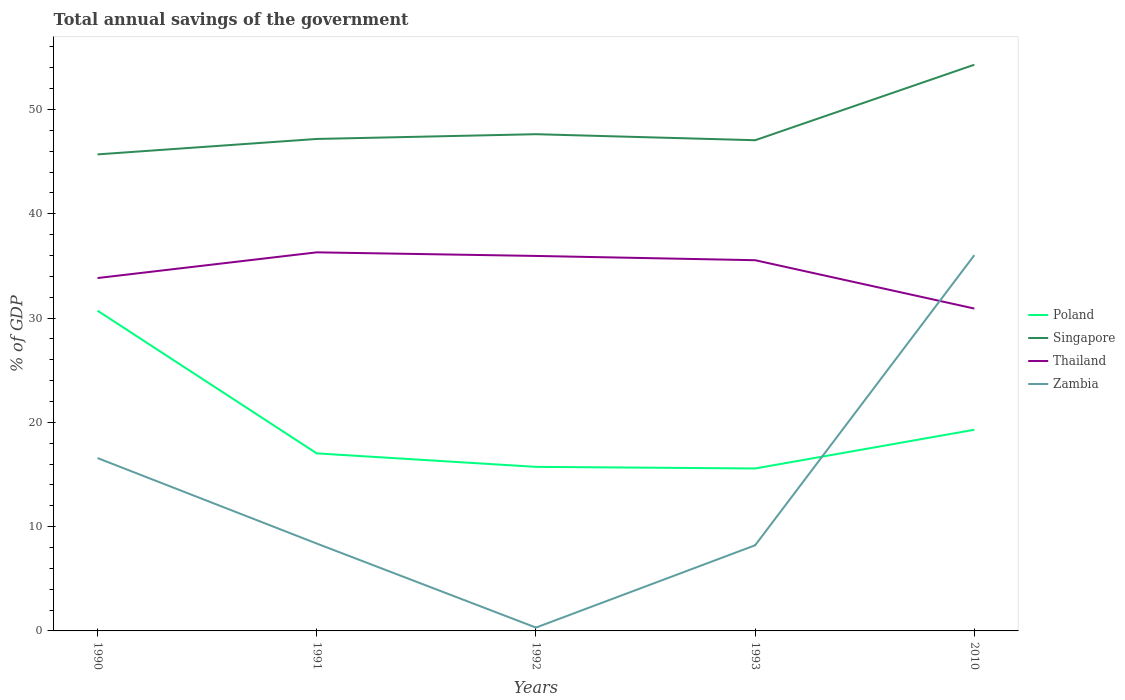How many different coloured lines are there?
Your response must be concise. 4. Does the line corresponding to Singapore intersect with the line corresponding to Thailand?
Provide a succinct answer. No. Across all years, what is the maximum total annual savings of the government in Poland?
Your response must be concise. 15.58. In which year was the total annual savings of the government in Zambia maximum?
Offer a terse response. 1992. What is the total total annual savings of the government in Zambia in the graph?
Provide a succinct answer. -7.89. What is the difference between the highest and the second highest total annual savings of the government in Thailand?
Ensure brevity in your answer.  5.39. How many years are there in the graph?
Your response must be concise. 5. Are the values on the major ticks of Y-axis written in scientific E-notation?
Your answer should be compact. No. Does the graph contain grids?
Keep it short and to the point. No. How are the legend labels stacked?
Ensure brevity in your answer.  Vertical. What is the title of the graph?
Ensure brevity in your answer.  Total annual savings of the government. What is the label or title of the X-axis?
Offer a terse response. Years. What is the label or title of the Y-axis?
Your answer should be very brief. % of GDP. What is the % of GDP of Poland in 1990?
Give a very brief answer. 30.7. What is the % of GDP of Singapore in 1990?
Offer a terse response. 45.69. What is the % of GDP in Thailand in 1990?
Offer a terse response. 33.84. What is the % of GDP in Zambia in 1990?
Provide a succinct answer. 16.57. What is the % of GDP of Poland in 1991?
Offer a terse response. 17.02. What is the % of GDP in Singapore in 1991?
Keep it short and to the point. 47.17. What is the % of GDP in Thailand in 1991?
Your answer should be compact. 36.3. What is the % of GDP of Zambia in 1991?
Your answer should be very brief. 8.38. What is the % of GDP in Poland in 1992?
Offer a very short reply. 15.73. What is the % of GDP of Singapore in 1992?
Offer a terse response. 47.63. What is the % of GDP in Thailand in 1992?
Offer a terse response. 35.95. What is the % of GDP in Zambia in 1992?
Keep it short and to the point. 0.32. What is the % of GDP in Poland in 1993?
Your answer should be very brief. 15.58. What is the % of GDP of Singapore in 1993?
Provide a succinct answer. 47.05. What is the % of GDP in Thailand in 1993?
Make the answer very short. 35.54. What is the % of GDP in Zambia in 1993?
Your answer should be very brief. 8.21. What is the % of GDP of Poland in 2010?
Keep it short and to the point. 19.29. What is the % of GDP of Singapore in 2010?
Provide a succinct answer. 54.29. What is the % of GDP of Thailand in 2010?
Offer a very short reply. 30.91. What is the % of GDP in Zambia in 2010?
Ensure brevity in your answer.  36.03. Across all years, what is the maximum % of GDP of Poland?
Ensure brevity in your answer.  30.7. Across all years, what is the maximum % of GDP of Singapore?
Your answer should be very brief. 54.29. Across all years, what is the maximum % of GDP of Thailand?
Keep it short and to the point. 36.3. Across all years, what is the maximum % of GDP in Zambia?
Your response must be concise. 36.03. Across all years, what is the minimum % of GDP in Poland?
Give a very brief answer. 15.58. Across all years, what is the minimum % of GDP in Singapore?
Ensure brevity in your answer.  45.69. Across all years, what is the minimum % of GDP of Thailand?
Provide a succinct answer. 30.91. Across all years, what is the minimum % of GDP in Zambia?
Your answer should be very brief. 0.32. What is the total % of GDP in Poland in the graph?
Your answer should be compact. 98.32. What is the total % of GDP in Singapore in the graph?
Make the answer very short. 241.83. What is the total % of GDP in Thailand in the graph?
Give a very brief answer. 172.54. What is the total % of GDP of Zambia in the graph?
Provide a succinct answer. 69.51. What is the difference between the % of GDP of Poland in 1990 and that in 1991?
Ensure brevity in your answer.  13.68. What is the difference between the % of GDP of Singapore in 1990 and that in 1991?
Offer a terse response. -1.48. What is the difference between the % of GDP of Thailand in 1990 and that in 1991?
Ensure brevity in your answer.  -2.46. What is the difference between the % of GDP of Zambia in 1990 and that in 1991?
Provide a succinct answer. 8.19. What is the difference between the % of GDP in Poland in 1990 and that in 1992?
Keep it short and to the point. 14.97. What is the difference between the % of GDP in Singapore in 1990 and that in 1992?
Give a very brief answer. -1.93. What is the difference between the % of GDP in Thailand in 1990 and that in 1992?
Your answer should be compact. -2.12. What is the difference between the % of GDP of Zambia in 1990 and that in 1992?
Offer a very short reply. 16.25. What is the difference between the % of GDP in Poland in 1990 and that in 1993?
Give a very brief answer. 15.13. What is the difference between the % of GDP in Singapore in 1990 and that in 1993?
Your answer should be compact. -1.36. What is the difference between the % of GDP of Thailand in 1990 and that in 1993?
Your response must be concise. -1.71. What is the difference between the % of GDP of Zambia in 1990 and that in 1993?
Make the answer very short. 8.36. What is the difference between the % of GDP in Poland in 1990 and that in 2010?
Offer a very short reply. 11.42. What is the difference between the % of GDP of Singapore in 1990 and that in 2010?
Your answer should be compact. -8.6. What is the difference between the % of GDP in Thailand in 1990 and that in 2010?
Your answer should be compact. 2.93. What is the difference between the % of GDP in Zambia in 1990 and that in 2010?
Keep it short and to the point. -19.46. What is the difference between the % of GDP of Poland in 1991 and that in 1992?
Provide a succinct answer. 1.29. What is the difference between the % of GDP of Singapore in 1991 and that in 1992?
Your answer should be compact. -0.46. What is the difference between the % of GDP of Thailand in 1991 and that in 1992?
Offer a terse response. 0.34. What is the difference between the % of GDP of Zambia in 1991 and that in 1992?
Offer a terse response. 8.06. What is the difference between the % of GDP in Poland in 1991 and that in 1993?
Give a very brief answer. 1.45. What is the difference between the % of GDP in Singapore in 1991 and that in 1993?
Offer a terse response. 0.12. What is the difference between the % of GDP of Thailand in 1991 and that in 1993?
Your response must be concise. 0.75. What is the difference between the % of GDP of Zambia in 1991 and that in 1993?
Keep it short and to the point. 0.17. What is the difference between the % of GDP of Poland in 1991 and that in 2010?
Provide a succinct answer. -2.27. What is the difference between the % of GDP in Singapore in 1991 and that in 2010?
Ensure brevity in your answer.  -7.12. What is the difference between the % of GDP of Thailand in 1991 and that in 2010?
Ensure brevity in your answer.  5.39. What is the difference between the % of GDP of Zambia in 1991 and that in 2010?
Your response must be concise. -27.65. What is the difference between the % of GDP of Poland in 1992 and that in 1993?
Keep it short and to the point. 0.15. What is the difference between the % of GDP of Singapore in 1992 and that in 1993?
Make the answer very short. 0.58. What is the difference between the % of GDP in Thailand in 1992 and that in 1993?
Keep it short and to the point. 0.41. What is the difference between the % of GDP in Zambia in 1992 and that in 1993?
Keep it short and to the point. -7.89. What is the difference between the % of GDP of Poland in 1992 and that in 2010?
Ensure brevity in your answer.  -3.56. What is the difference between the % of GDP in Singapore in 1992 and that in 2010?
Make the answer very short. -6.66. What is the difference between the % of GDP in Thailand in 1992 and that in 2010?
Provide a short and direct response. 5.05. What is the difference between the % of GDP of Zambia in 1992 and that in 2010?
Your answer should be compact. -35.71. What is the difference between the % of GDP in Poland in 1993 and that in 2010?
Your response must be concise. -3.71. What is the difference between the % of GDP of Singapore in 1993 and that in 2010?
Ensure brevity in your answer.  -7.24. What is the difference between the % of GDP in Thailand in 1993 and that in 2010?
Give a very brief answer. 4.64. What is the difference between the % of GDP in Zambia in 1993 and that in 2010?
Make the answer very short. -27.82. What is the difference between the % of GDP of Poland in 1990 and the % of GDP of Singapore in 1991?
Your answer should be compact. -16.47. What is the difference between the % of GDP in Poland in 1990 and the % of GDP in Thailand in 1991?
Offer a terse response. -5.59. What is the difference between the % of GDP in Poland in 1990 and the % of GDP in Zambia in 1991?
Your answer should be compact. 22.33. What is the difference between the % of GDP of Singapore in 1990 and the % of GDP of Thailand in 1991?
Your response must be concise. 9.39. What is the difference between the % of GDP in Singapore in 1990 and the % of GDP in Zambia in 1991?
Offer a very short reply. 37.31. What is the difference between the % of GDP of Thailand in 1990 and the % of GDP of Zambia in 1991?
Ensure brevity in your answer.  25.46. What is the difference between the % of GDP of Poland in 1990 and the % of GDP of Singapore in 1992?
Make the answer very short. -16.92. What is the difference between the % of GDP of Poland in 1990 and the % of GDP of Thailand in 1992?
Make the answer very short. -5.25. What is the difference between the % of GDP in Poland in 1990 and the % of GDP in Zambia in 1992?
Your answer should be compact. 30.38. What is the difference between the % of GDP in Singapore in 1990 and the % of GDP in Thailand in 1992?
Give a very brief answer. 9.74. What is the difference between the % of GDP of Singapore in 1990 and the % of GDP of Zambia in 1992?
Offer a terse response. 45.37. What is the difference between the % of GDP in Thailand in 1990 and the % of GDP in Zambia in 1992?
Your answer should be compact. 33.51. What is the difference between the % of GDP of Poland in 1990 and the % of GDP of Singapore in 1993?
Your answer should be compact. -16.34. What is the difference between the % of GDP in Poland in 1990 and the % of GDP in Thailand in 1993?
Provide a short and direct response. -4.84. What is the difference between the % of GDP in Poland in 1990 and the % of GDP in Zambia in 1993?
Your answer should be compact. 22.49. What is the difference between the % of GDP of Singapore in 1990 and the % of GDP of Thailand in 1993?
Your answer should be very brief. 10.15. What is the difference between the % of GDP in Singapore in 1990 and the % of GDP in Zambia in 1993?
Offer a very short reply. 37.48. What is the difference between the % of GDP in Thailand in 1990 and the % of GDP in Zambia in 1993?
Ensure brevity in your answer.  25.62. What is the difference between the % of GDP in Poland in 1990 and the % of GDP in Singapore in 2010?
Offer a terse response. -23.58. What is the difference between the % of GDP of Poland in 1990 and the % of GDP of Thailand in 2010?
Your answer should be compact. -0.2. What is the difference between the % of GDP of Poland in 1990 and the % of GDP of Zambia in 2010?
Offer a very short reply. -5.32. What is the difference between the % of GDP in Singapore in 1990 and the % of GDP in Thailand in 2010?
Your response must be concise. 14.78. What is the difference between the % of GDP of Singapore in 1990 and the % of GDP of Zambia in 2010?
Make the answer very short. 9.66. What is the difference between the % of GDP in Thailand in 1990 and the % of GDP in Zambia in 2010?
Make the answer very short. -2.19. What is the difference between the % of GDP in Poland in 1991 and the % of GDP in Singapore in 1992?
Your response must be concise. -30.6. What is the difference between the % of GDP in Poland in 1991 and the % of GDP in Thailand in 1992?
Your response must be concise. -18.93. What is the difference between the % of GDP in Poland in 1991 and the % of GDP in Zambia in 1992?
Your response must be concise. 16.7. What is the difference between the % of GDP in Singapore in 1991 and the % of GDP in Thailand in 1992?
Your answer should be very brief. 11.22. What is the difference between the % of GDP in Singapore in 1991 and the % of GDP in Zambia in 1992?
Ensure brevity in your answer.  46.85. What is the difference between the % of GDP of Thailand in 1991 and the % of GDP of Zambia in 1992?
Your answer should be compact. 35.98. What is the difference between the % of GDP of Poland in 1991 and the % of GDP of Singapore in 1993?
Provide a short and direct response. -30.03. What is the difference between the % of GDP of Poland in 1991 and the % of GDP of Thailand in 1993?
Your response must be concise. -18.52. What is the difference between the % of GDP in Poland in 1991 and the % of GDP in Zambia in 1993?
Provide a succinct answer. 8.81. What is the difference between the % of GDP of Singapore in 1991 and the % of GDP of Thailand in 1993?
Your response must be concise. 11.63. What is the difference between the % of GDP in Singapore in 1991 and the % of GDP in Zambia in 1993?
Offer a terse response. 38.96. What is the difference between the % of GDP of Thailand in 1991 and the % of GDP of Zambia in 1993?
Your answer should be very brief. 28.09. What is the difference between the % of GDP in Poland in 1991 and the % of GDP in Singapore in 2010?
Keep it short and to the point. -37.27. What is the difference between the % of GDP of Poland in 1991 and the % of GDP of Thailand in 2010?
Your answer should be very brief. -13.89. What is the difference between the % of GDP in Poland in 1991 and the % of GDP in Zambia in 2010?
Make the answer very short. -19.01. What is the difference between the % of GDP in Singapore in 1991 and the % of GDP in Thailand in 2010?
Keep it short and to the point. 16.26. What is the difference between the % of GDP of Singapore in 1991 and the % of GDP of Zambia in 2010?
Your response must be concise. 11.14. What is the difference between the % of GDP of Thailand in 1991 and the % of GDP of Zambia in 2010?
Offer a very short reply. 0.27. What is the difference between the % of GDP in Poland in 1992 and the % of GDP in Singapore in 1993?
Keep it short and to the point. -31.32. What is the difference between the % of GDP in Poland in 1992 and the % of GDP in Thailand in 1993?
Ensure brevity in your answer.  -19.81. What is the difference between the % of GDP of Poland in 1992 and the % of GDP of Zambia in 1993?
Offer a terse response. 7.52. What is the difference between the % of GDP of Singapore in 1992 and the % of GDP of Thailand in 1993?
Offer a terse response. 12.08. What is the difference between the % of GDP in Singapore in 1992 and the % of GDP in Zambia in 1993?
Ensure brevity in your answer.  39.41. What is the difference between the % of GDP in Thailand in 1992 and the % of GDP in Zambia in 1993?
Provide a short and direct response. 27.74. What is the difference between the % of GDP of Poland in 1992 and the % of GDP of Singapore in 2010?
Keep it short and to the point. -38.56. What is the difference between the % of GDP in Poland in 1992 and the % of GDP in Thailand in 2010?
Your answer should be very brief. -15.18. What is the difference between the % of GDP of Poland in 1992 and the % of GDP of Zambia in 2010?
Your answer should be compact. -20.3. What is the difference between the % of GDP in Singapore in 1992 and the % of GDP in Thailand in 2010?
Provide a short and direct response. 16.72. What is the difference between the % of GDP in Singapore in 1992 and the % of GDP in Zambia in 2010?
Provide a succinct answer. 11.6. What is the difference between the % of GDP of Thailand in 1992 and the % of GDP of Zambia in 2010?
Provide a succinct answer. -0.07. What is the difference between the % of GDP in Poland in 1993 and the % of GDP in Singapore in 2010?
Give a very brief answer. -38.71. What is the difference between the % of GDP in Poland in 1993 and the % of GDP in Thailand in 2010?
Your response must be concise. -15.33. What is the difference between the % of GDP of Poland in 1993 and the % of GDP of Zambia in 2010?
Provide a succinct answer. -20.45. What is the difference between the % of GDP in Singapore in 1993 and the % of GDP in Thailand in 2010?
Your answer should be very brief. 16.14. What is the difference between the % of GDP in Singapore in 1993 and the % of GDP in Zambia in 2010?
Offer a terse response. 11.02. What is the difference between the % of GDP of Thailand in 1993 and the % of GDP of Zambia in 2010?
Give a very brief answer. -0.48. What is the average % of GDP of Poland per year?
Offer a terse response. 19.66. What is the average % of GDP of Singapore per year?
Offer a very short reply. 48.37. What is the average % of GDP in Thailand per year?
Make the answer very short. 34.51. What is the average % of GDP of Zambia per year?
Provide a short and direct response. 13.9. In the year 1990, what is the difference between the % of GDP of Poland and % of GDP of Singapore?
Offer a very short reply. -14.99. In the year 1990, what is the difference between the % of GDP of Poland and % of GDP of Thailand?
Your answer should be very brief. -3.13. In the year 1990, what is the difference between the % of GDP in Poland and % of GDP in Zambia?
Your answer should be compact. 14.13. In the year 1990, what is the difference between the % of GDP in Singapore and % of GDP in Thailand?
Provide a succinct answer. 11.86. In the year 1990, what is the difference between the % of GDP in Singapore and % of GDP in Zambia?
Make the answer very short. 29.12. In the year 1990, what is the difference between the % of GDP of Thailand and % of GDP of Zambia?
Keep it short and to the point. 17.26. In the year 1991, what is the difference between the % of GDP in Poland and % of GDP in Singapore?
Offer a terse response. -30.15. In the year 1991, what is the difference between the % of GDP in Poland and % of GDP in Thailand?
Keep it short and to the point. -19.28. In the year 1991, what is the difference between the % of GDP in Poland and % of GDP in Zambia?
Your response must be concise. 8.65. In the year 1991, what is the difference between the % of GDP of Singapore and % of GDP of Thailand?
Make the answer very short. 10.87. In the year 1991, what is the difference between the % of GDP of Singapore and % of GDP of Zambia?
Give a very brief answer. 38.79. In the year 1991, what is the difference between the % of GDP of Thailand and % of GDP of Zambia?
Offer a very short reply. 27.92. In the year 1992, what is the difference between the % of GDP of Poland and % of GDP of Singapore?
Keep it short and to the point. -31.9. In the year 1992, what is the difference between the % of GDP of Poland and % of GDP of Thailand?
Your response must be concise. -20.22. In the year 1992, what is the difference between the % of GDP of Poland and % of GDP of Zambia?
Your answer should be compact. 15.41. In the year 1992, what is the difference between the % of GDP in Singapore and % of GDP in Thailand?
Provide a short and direct response. 11.67. In the year 1992, what is the difference between the % of GDP in Singapore and % of GDP in Zambia?
Offer a terse response. 47.31. In the year 1992, what is the difference between the % of GDP of Thailand and % of GDP of Zambia?
Give a very brief answer. 35.63. In the year 1993, what is the difference between the % of GDP in Poland and % of GDP in Singapore?
Provide a short and direct response. -31.47. In the year 1993, what is the difference between the % of GDP of Poland and % of GDP of Thailand?
Make the answer very short. -19.97. In the year 1993, what is the difference between the % of GDP in Poland and % of GDP in Zambia?
Ensure brevity in your answer.  7.36. In the year 1993, what is the difference between the % of GDP of Singapore and % of GDP of Thailand?
Keep it short and to the point. 11.5. In the year 1993, what is the difference between the % of GDP of Singapore and % of GDP of Zambia?
Make the answer very short. 38.84. In the year 1993, what is the difference between the % of GDP in Thailand and % of GDP in Zambia?
Keep it short and to the point. 27.33. In the year 2010, what is the difference between the % of GDP of Poland and % of GDP of Singapore?
Give a very brief answer. -35. In the year 2010, what is the difference between the % of GDP of Poland and % of GDP of Thailand?
Ensure brevity in your answer.  -11.62. In the year 2010, what is the difference between the % of GDP of Poland and % of GDP of Zambia?
Offer a very short reply. -16.74. In the year 2010, what is the difference between the % of GDP in Singapore and % of GDP in Thailand?
Provide a succinct answer. 23.38. In the year 2010, what is the difference between the % of GDP in Singapore and % of GDP in Zambia?
Make the answer very short. 18.26. In the year 2010, what is the difference between the % of GDP in Thailand and % of GDP in Zambia?
Your answer should be very brief. -5.12. What is the ratio of the % of GDP in Poland in 1990 to that in 1991?
Keep it short and to the point. 1.8. What is the ratio of the % of GDP in Singapore in 1990 to that in 1991?
Your answer should be very brief. 0.97. What is the ratio of the % of GDP of Thailand in 1990 to that in 1991?
Give a very brief answer. 0.93. What is the ratio of the % of GDP in Zambia in 1990 to that in 1991?
Give a very brief answer. 1.98. What is the ratio of the % of GDP in Poland in 1990 to that in 1992?
Your answer should be compact. 1.95. What is the ratio of the % of GDP in Singapore in 1990 to that in 1992?
Give a very brief answer. 0.96. What is the ratio of the % of GDP of Thailand in 1990 to that in 1992?
Your response must be concise. 0.94. What is the ratio of the % of GDP in Zambia in 1990 to that in 1992?
Keep it short and to the point. 51.68. What is the ratio of the % of GDP in Poland in 1990 to that in 1993?
Provide a succinct answer. 1.97. What is the ratio of the % of GDP of Singapore in 1990 to that in 1993?
Make the answer very short. 0.97. What is the ratio of the % of GDP of Thailand in 1990 to that in 1993?
Your answer should be very brief. 0.95. What is the ratio of the % of GDP in Zambia in 1990 to that in 1993?
Your answer should be compact. 2.02. What is the ratio of the % of GDP of Poland in 1990 to that in 2010?
Provide a succinct answer. 1.59. What is the ratio of the % of GDP in Singapore in 1990 to that in 2010?
Keep it short and to the point. 0.84. What is the ratio of the % of GDP of Thailand in 1990 to that in 2010?
Keep it short and to the point. 1.09. What is the ratio of the % of GDP in Zambia in 1990 to that in 2010?
Your response must be concise. 0.46. What is the ratio of the % of GDP in Poland in 1991 to that in 1992?
Your response must be concise. 1.08. What is the ratio of the % of GDP of Thailand in 1991 to that in 1992?
Offer a very short reply. 1.01. What is the ratio of the % of GDP of Zambia in 1991 to that in 1992?
Offer a very short reply. 26.13. What is the ratio of the % of GDP in Poland in 1991 to that in 1993?
Give a very brief answer. 1.09. What is the ratio of the % of GDP of Thailand in 1991 to that in 1993?
Make the answer very short. 1.02. What is the ratio of the % of GDP of Zambia in 1991 to that in 1993?
Your answer should be compact. 1.02. What is the ratio of the % of GDP in Poland in 1991 to that in 2010?
Offer a very short reply. 0.88. What is the ratio of the % of GDP of Singapore in 1991 to that in 2010?
Give a very brief answer. 0.87. What is the ratio of the % of GDP in Thailand in 1991 to that in 2010?
Your answer should be very brief. 1.17. What is the ratio of the % of GDP in Zambia in 1991 to that in 2010?
Your answer should be compact. 0.23. What is the ratio of the % of GDP of Poland in 1992 to that in 1993?
Give a very brief answer. 1.01. What is the ratio of the % of GDP of Singapore in 1992 to that in 1993?
Ensure brevity in your answer.  1.01. What is the ratio of the % of GDP in Thailand in 1992 to that in 1993?
Keep it short and to the point. 1.01. What is the ratio of the % of GDP in Zambia in 1992 to that in 1993?
Your response must be concise. 0.04. What is the ratio of the % of GDP of Poland in 1992 to that in 2010?
Ensure brevity in your answer.  0.82. What is the ratio of the % of GDP in Singapore in 1992 to that in 2010?
Keep it short and to the point. 0.88. What is the ratio of the % of GDP in Thailand in 1992 to that in 2010?
Keep it short and to the point. 1.16. What is the ratio of the % of GDP of Zambia in 1992 to that in 2010?
Give a very brief answer. 0.01. What is the ratio of the % of GDP in Poland in 1993 to that in 2010?
Provide a succinct answer. 0.81. What is the ratio of the % of GDP of Singapore in 1993 to that in 2010?
Provide a short and direct response. 0.87. What is the ratio of the % of GDP in Thailand in 1993 to that in 2010?
Ensure brevity in your answer.  1.15. What is the ratio of the % of GDP of Zambia in 1993 to that in 2010?
Your answer should be compact. 0.23. What is the difference between the highest and the second highest % of GDP in Poland?
Keep it short and to the point. 11.42. What is the difference between the highest and the second highest % of GDP in Singapore?
Ensure brevity in your answer.  6.66. What is the difference between the highest and the second highest % of GDP of Thailand?
Keep it short and to the point. 0.34. What is the difference between the highest and the second highest % of GDP of Zambia?
Keep it short and to the point. 19.46. What is the difference between the highest and the lowest % of GDP in Poland?
Keep it short and to the point. 15.13. What is the difference between the highest and the lowest % of GDP in Singapore?
Give a very brief answer. 8.6. What is the difference between the highest and the lowest % of GDP of Thailand?
Your answer should be compact. 5.39. What is the difference between the highest and the lowest % of GDP of Zambia?
Your response must be concise. 35.71. 